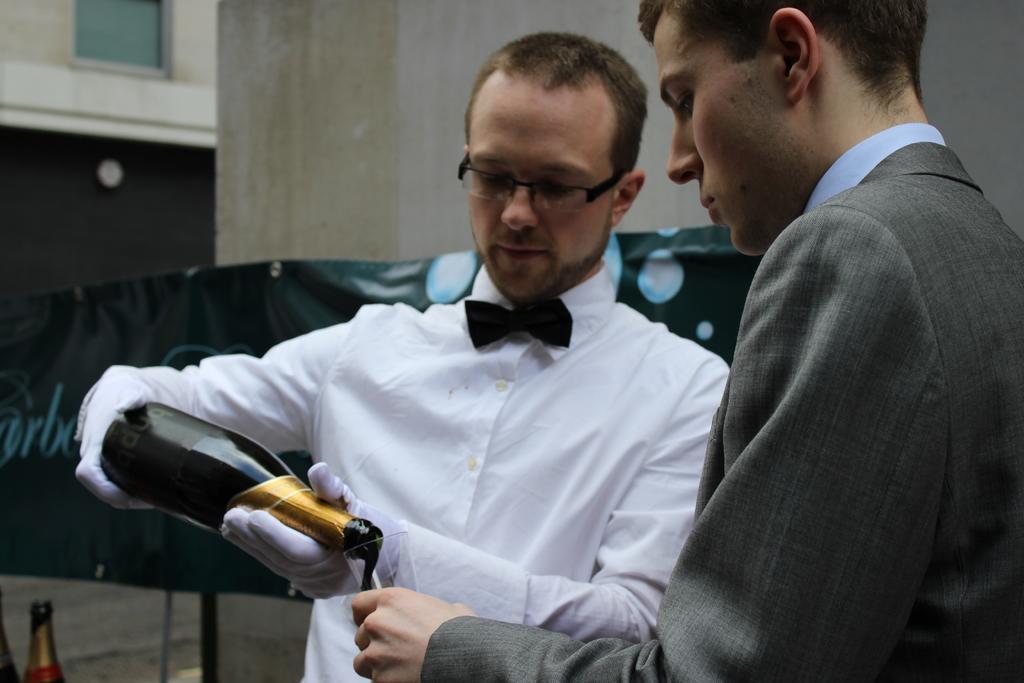Please provide a concise description of this image. Here we can see two men standing and the guy in left side is holding a bottle and pouring the champagne in the glass held by the man in the right side 